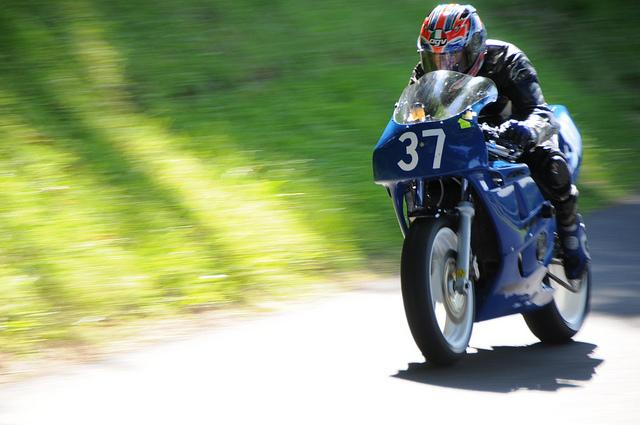Is the rider wearing a helmet?
Answer briefly. Yes. What number is on the bike?
Be succinct. 37. What is the bike number in front of the race?
Quick response, please. 37. What is he riding?
Write a very short answer. Motorcycle. 